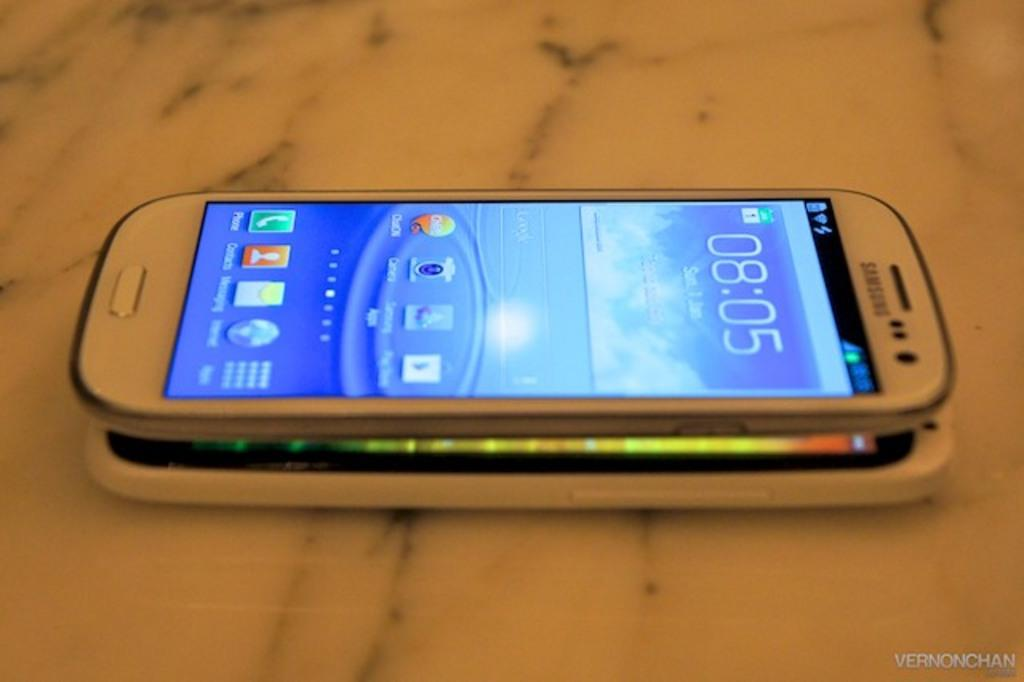Provide a one-sentence caption for the provided image. A smart phone is stacked on top of another smart phone at 8:05. 